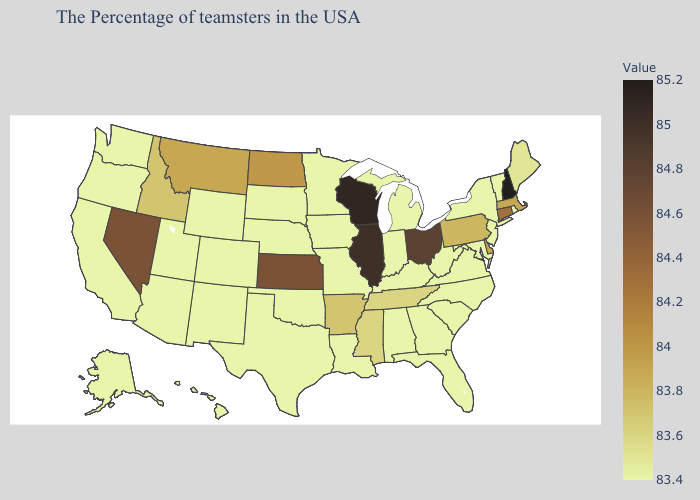Among the states that border Alabama , does Mississippi have the highest value?
Keep it brief. Yes. Which states have the lowest value in the USA?
Concise answer only. Rhode Island, Vermont, New York, New Jersey, Maryland, Virginia, North Carolina, South Carolina, West Virginia, Florida, Georgia, Michigan, Kentucky, Indiana, Alabama, Louisiana, Missouri, Minnesota, Iowa, Nebraska, Oklahoma, Texas, South Dakota, Wyoming, Colorado, New Mexico, Utah, Arizona, California, Washington, Oregon, Alaska, Hawaii. Which states have the highest value in the USA?
Be succinct. New Hampshire. Is the legend a continuous bar?
Keep it brief. Yes. Does the map have missing data?
Give a very brief answer. No. Does Hawaii have a lower value than New Hampshire?
Concise answer only. Yes. 